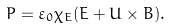<formula> <loc_0><loc_0><loc_500><loc_500>P = \varepsilon _ { 0 } \chi _ { E } ( E + U \times B ) .</formula> 